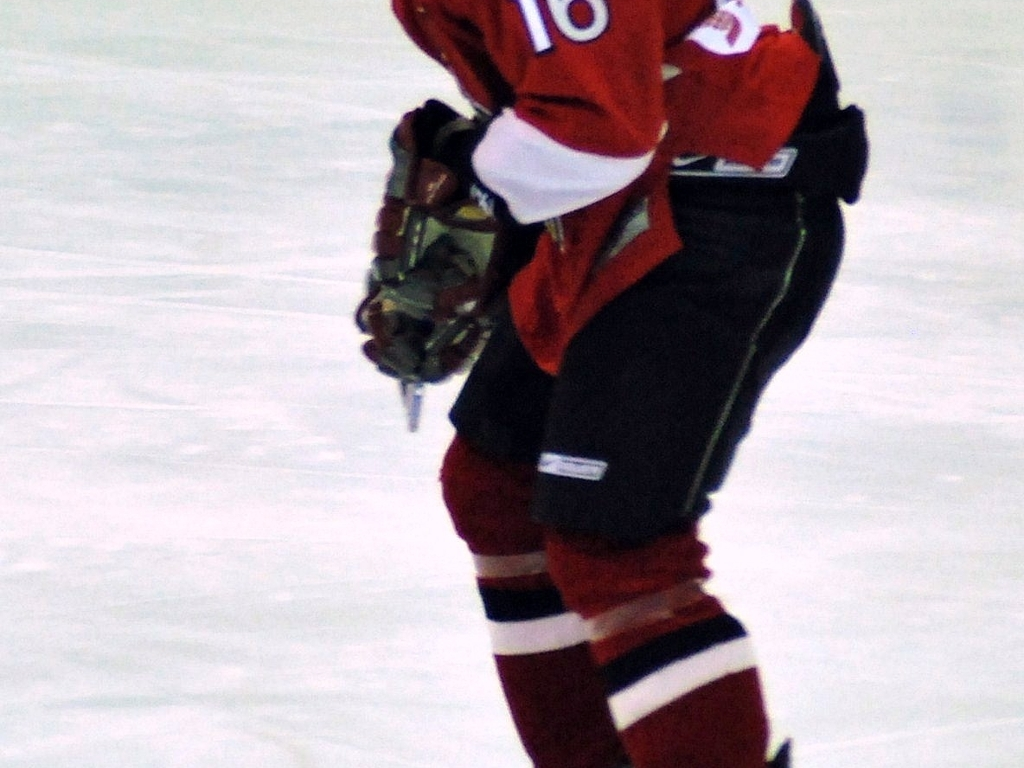What sport is this person likely participating in? Given the attire, such as the jersey, protective padding, and ice skates, it is likely that the individual is participating in ice hockey. 